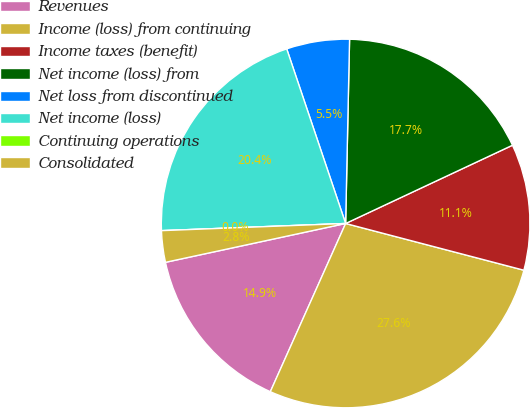<chart> <loc_0><loc_0><loc_500><loc_500><pie_chart><fcel>Revenues<fcel>Income (loss) from continuing<fcel>Income taxes (benefit)<fcel>Net income (loss) from<fcel>Net loss from discontinued<fcel>Net income (loss)<fcel>Continuing operations<fcel>Consolidated<nl><fcel>14.92%<fcel>27.62%<fcel>11.06%<fcel>17.68%<fcel>5.52%<fcel>20.44%<fcel>0.0%<fcel>2.76%<nl></chart> 